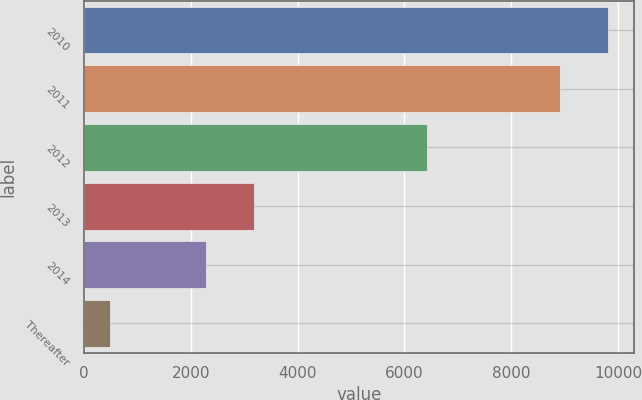Convert chart to OTSL. <chart><loc_0><loc_0><loc_500><loc_500><bar_chart><fcel>2010<fcel>2011<fcel>2012<fcel>2013<fcel>2014<fcel>Thereafter<nl><fcel>9813.3<fcel>8922<fcel>6423<fcel>3181.3<fcel>2290<fcel>477<nl></chart> 